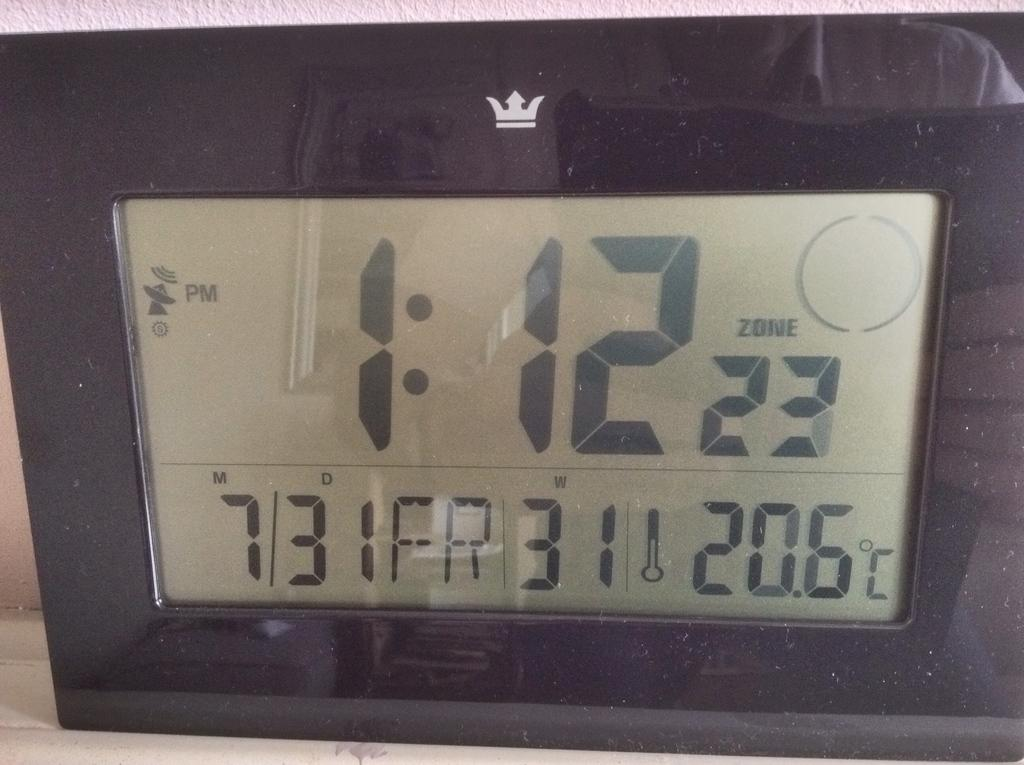<image>
Provide a brief description of the given image. A digital display showing the time 1:12 PM on 7/31. 